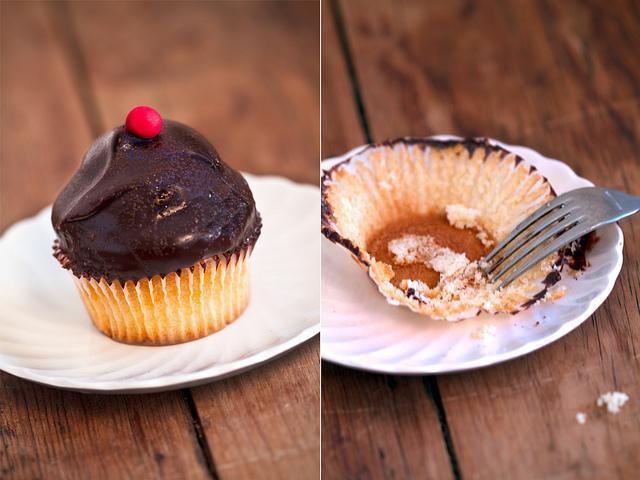How many dining tables are there?
Give a very brief answer. 2. How many brown horses are in the grass?
Give a very brief answer. 0. 